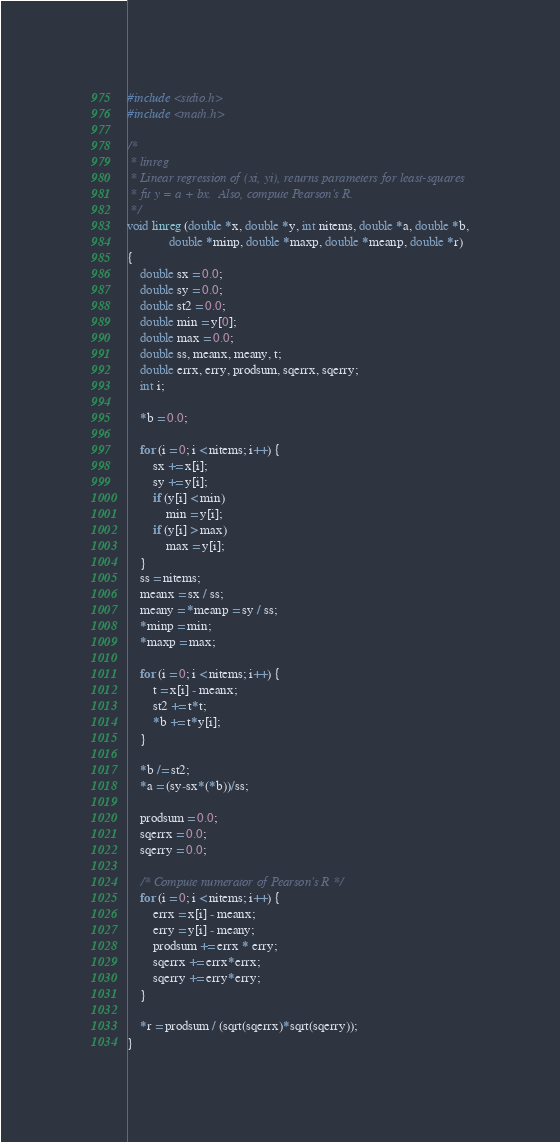<code> <loc_0><loc_0><loc_500><loc_500><_C_>
#include <stdio.h>
#include <math.h>

/*
 * linreg
 * Linear regression of (xi, yi), returns parameters for least-squares
 * fit y = a + bx.  Also, compute Pearson's R.
 */
void linreg (double *x, double *y, int nitems, double *a, double *b,
             double *minp, double *maxp, double *meanp, double *r)
{
    double sx = 0.0;
    double sy = 0.0;
    double st2 = 0.0;
    double min = y[0];
    double max = 0.0;
    double ss, meanx, meany, t;
    double errx, erry, prodsum, sqerrx, sqerry;
    int i;

    *b = 0.0;
    
    for (i = 0; i < nitems; i++) {
        sx += x[i];
        sy += y[i];
        if (y[i] < min)
            min = y[i];
        if (y[i] > max)
            max = y[i];
    }
    ss = nitems;
    meanx = sx / ss;
    meany = *meanp = sy / ss;
    *minp = min;
    *maxp = max;

    for (i = 0; i < nitems; i++) {
        t = x[i] - meanx;
        st2 += t*t;
        *b += t*y[i];
    }

    *b /= st2;
    *a = (sy-sx*(*b))/ss;

    prodsum = 0.0;
    sqerrx = 0.0;
    sqerry = 0.0;

    /* Compute numerator of Pearson's R */
    for (i = 0; i < nitems; i++) {
        errx = x[i] - meanx;
        erry = y[i] - meany;
        prodsum += errx * erry;
        sqerrx += errx*errx;
        sqerry += erry*erry;
    }

    *r = prodsum / (sqrt(sqerrx)*sqrt(sqerry));
}
</code> 